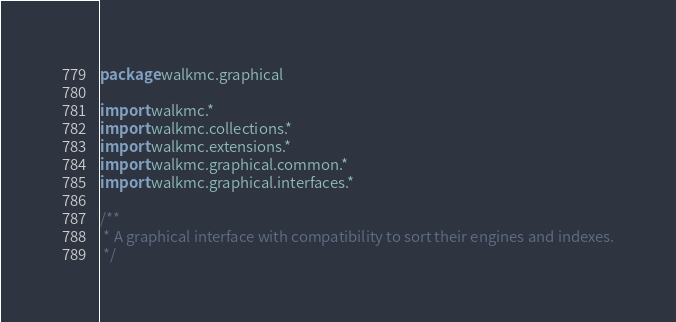<code> <loc_0><loc_0><loc_500><loc_500><_Kotlin_>package walkmc.graphical

import walkmc.*
import walkmc.collections.*
import walkmc.extensions.*
import walkmc.graphical.common.*
import walkmc.graphical.interfaces.*

/**
 * A graphical interface with compatibility to sort their engines and indexes.
 */</code> 